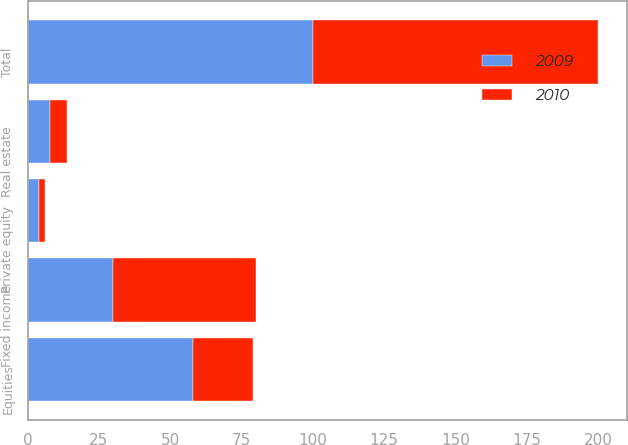<chart> <loc_0><loc_0><loc_500><loc_500><stacked_bar_chart><ecel><fcel>Equities<fcel>Fixed income<fcel>Real estate<fcel>Private equity<fcel>Total<nl><fcel>2010<fcel>21<fcel>50<fcel>6<fcel>2<fcel>100<nl><fcel>2009<fcel>58<fcel>30<fcel>8<fcel>4<fcel>100<nl></chart> 